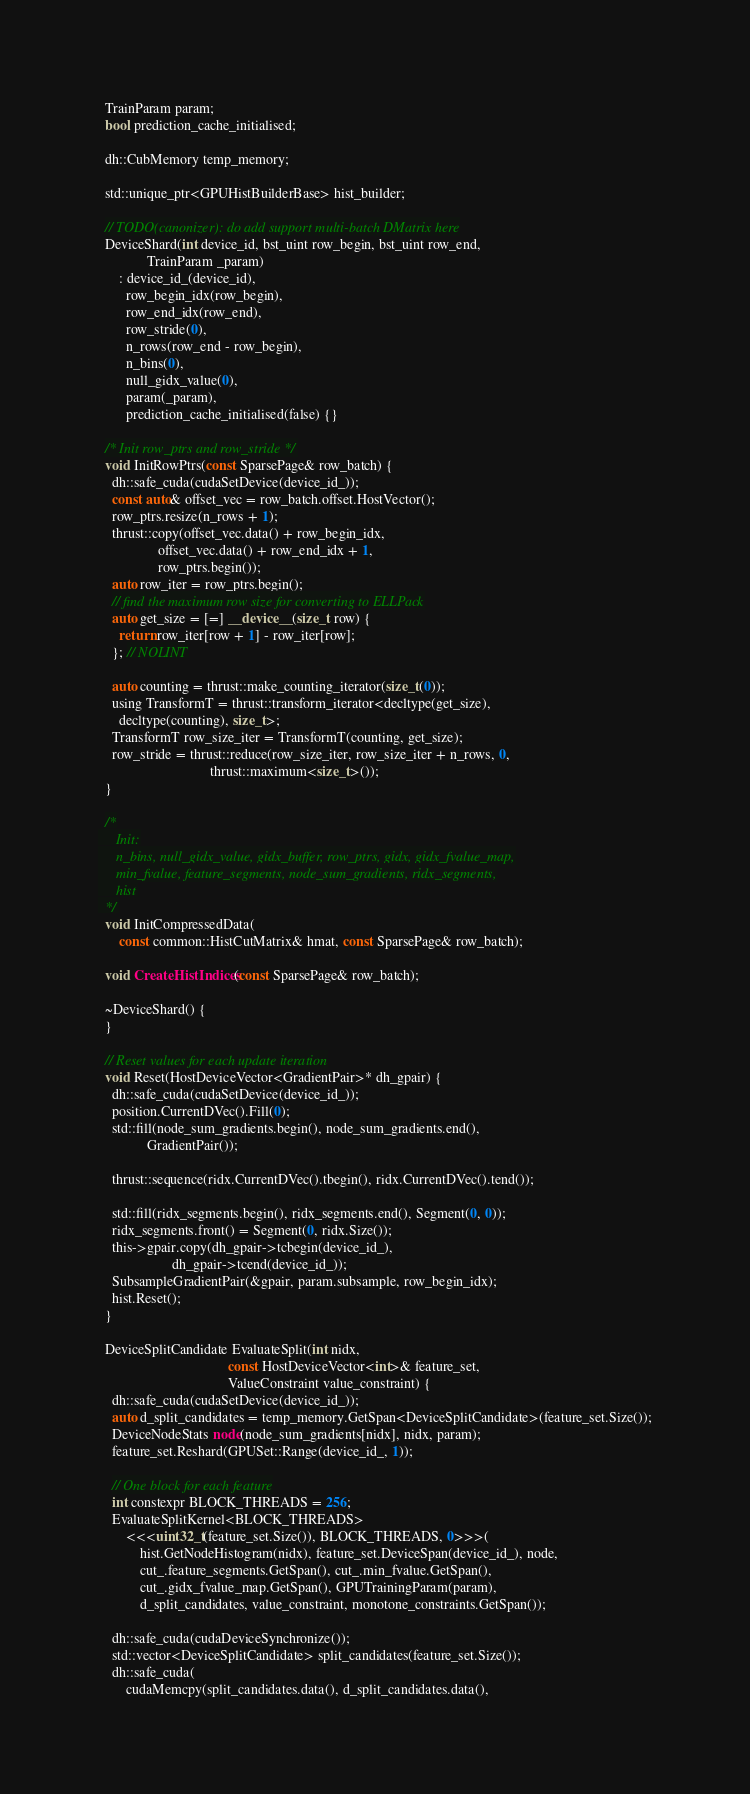<code> <loc_0><loc_0><loc_500><loc_500><_Cuda_>
  TrainParam param;
  bool prediction_cache_initialised;

  dh::CubMemory temp_memory;

  std::unique_ptr<GPUHistBuilderBase> hist_builder;

  // TODO(canonizer): do add support multi-batch DMatrix here
  DeviceShard(int device_id, bst_uint row_begin, bst_uint row_end,
              TrainParam _param)
      : device_id_(device_id),
        row_begin_idx(row_begin),
        row_end_idx(row_end),
        row_stride(0),
        n_rows(row_end - row_begin),
        n_bins(0),
        null_gidx_value(0),
        param(_param),
        prediction_cache_initialised(false) {}

  /* Init row_ptrs and row_stride */
  void InitRowPtrs(const SparsePage& row_batch) {
    dh::safe_cuda(cudaSetDevice(device_id_));
    const auto& offset_vec = row_batch.offset.HostVector();
    row_ptrs.resize(n_rows + 1);
    thrust::copy(offset_vec.data() + row_begin_idx,
                 offset_vec.data() + row_end_idx + 1,
                 row_ptrs.begin());
    auto row_iter = row_ptrs.begin();
    // find the maximum row size for converting to ELLPack
    auto get_size = [=] __device__(size_t row) {
      return row_iter[row + 1] - row_iter[row];
    }; // NOLINT

    auto counting = thrust::make_counting_iterator(size_t(0));
    using TransformT = thrust::transform_iterator<decltype(get_size),
      decltype(counting), size_t>;
    TransformT row_size_iter = TransformT(counting, get_size);
    row_stride = thrust::reduce(row_size_iter, row_size_iter + n_rows, 0,
                                thrust::maximum<size_t>());
  }

  /*
     Init:
     n_bins, null_gidx_value, gidx_buffer, row_ptrs, gidx, gidx_fvalue_map,
     min_fvalue, feature_segments, node_sum_gradients, ridx_segments,
     hist
  */
  void InitCompressedData(
      const common::HistCutMatrix& hmat, const SparsePage& row_batch);

  void CreateHistIndices(const SparsePage& row_batch);

  ~DeviceShard() {
  }

  // Reset values for each update iteration
  void Reset(HostDeviceVector<GradientPair>* dh_gpair) {
    dh::safe_cuda(cudaSetDevice(device_id_));
    position.CurrentDVec().Fill(0);
    std::fill(node_sum_gradients.begin(), node_sum_gradients.end(),
              GradientPair());

    thrust::sequence(ridx.CurrentDVec().tbegin(), ridx.CurrentDVec().tend());

    std::fill(ridx_segments.begin(), ridx_segments.end(), Segment(0, 0));
    ridx_segments.front() = Segment(0, ridx.Size());
    this->gpair.copy(dh_gpair->tcbegin(device_id_),
                     dh_gpair->tcend(device_id_));
    SubsampleGradientPair(&gpair, param.subsample, row_begin_idx);
    hist.Reset();
  }

  DeviceSplitCandidate EvaluateSplit(int nidx,
                                     const HostDeviceVector<int>& feature_set,
                                     ValueConstraint value_constraint) {
    dh::safe_cuda(cudaSetDevice(device_id_));
    auto d_split_candidates = temp_memory.GetSpan<DeviceSplitCandidate>(feature_set.Size());
    DeviceNodeStats node(node_sum_gradients[nidx], nidx, param);
    feature_set.Reshard(GPUSet::Range(device_id_, 1));

    // One block for each feature
    int constexpr BLOCK_THREADS = 256;
    EvaluateSplitKernel<BLOCK_THREADS>
        <<<uint32_t(feature_set.Size()), BLOCK_THREADS, 0>>>(
            hist.GetNodeHistogram(nidx), feature_set.DeviceSpan(device_id_), node,
            cut_.feature_segments.GetSpan(), cut_.min_fvalue.GetSpan(),
            cut_.gidx_fvalue_map.GetSpan(), GPUTrainingParam(param),
            d_split_candidates, value_constraint, monotone_constraints.GetSpan());

    dh::safe_cuda(cudaDeviceSynchronize());
    std::vector<DeviceSplitCandidate> split_candidates(feature_set.Size());
    dh::safe_cuda(
        cudaMemcpy(split_candidates.data(), d_split_candidates.data(),</code> 